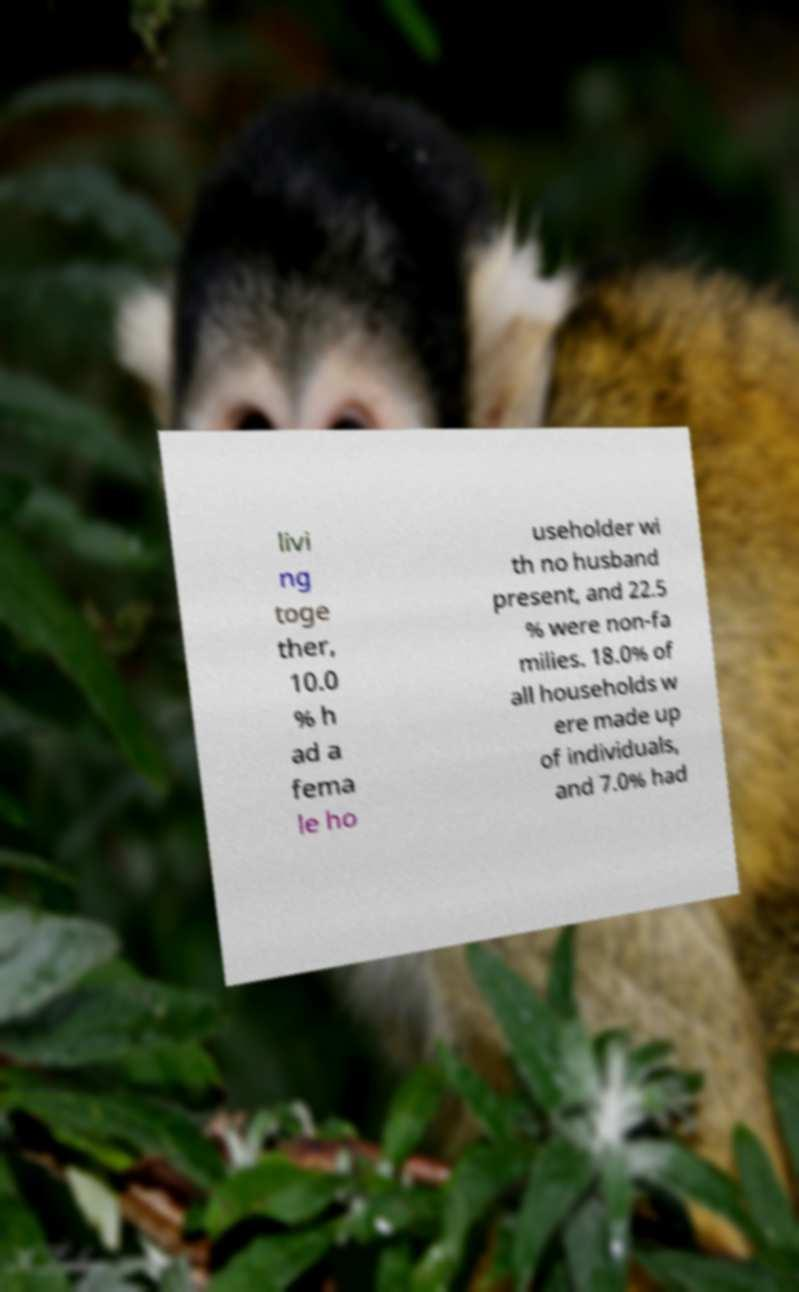For documentation purposes, I need the text within this image transcribed. Could you provide that? livi ng toge ther, 10.0 % h ad a fema le ho useholder wi th no husband present, and 22.5 % were non-fa milies. 18.0% of all households w ere made up of individuals, and 7.0% had 